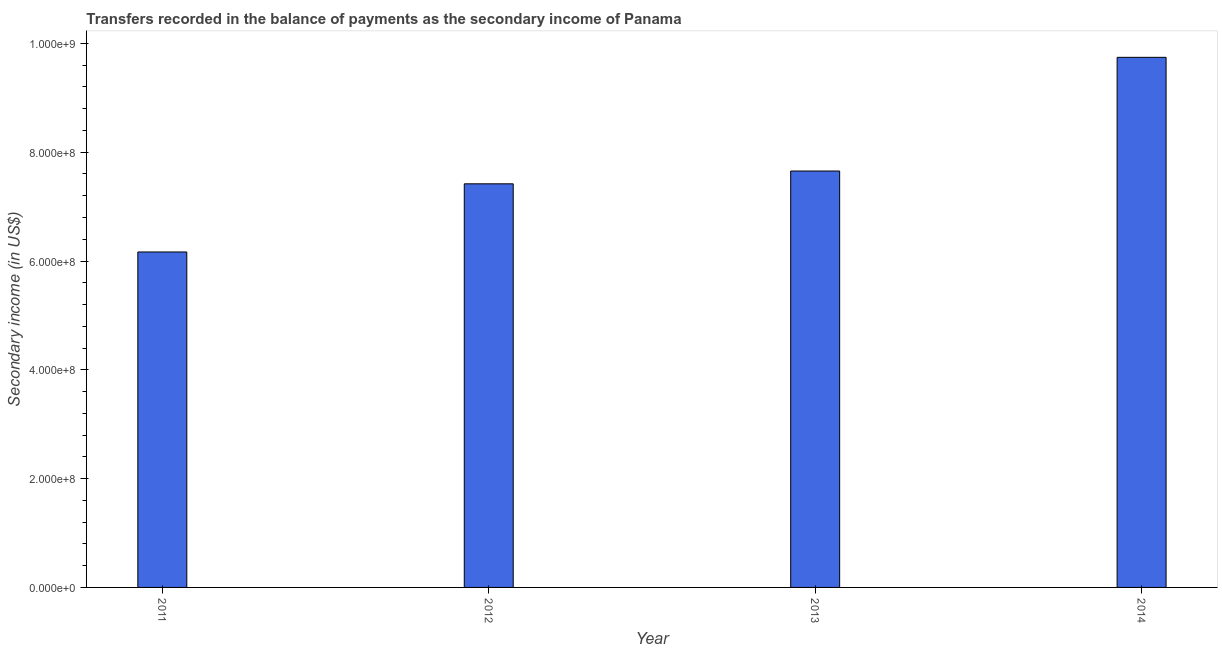Does the graph contain any zero values?
Ensure brevity in your answer.  No. What is the title of the graph?
Keep it short and to the point. Transfers recorded in the balance of payments as the secondary income of Panama. What is the label or title of the X-axis?
Ensure brevity in your answer.  Year. What is the label or title of the Y-axis?
Your answer should be very brief. Secondary income (in US$). What is the amount of secondary income in 2013?
Your response must be concise. 7.65e+08. Across all years, what is the maximum amount of secondary income?
Provide a succinct answer. 9.74e+08. Across all years, what is the minimum amount of secondary income?
Keep it short and to the point. 6.17e+08. What is the sum of the amount of secondary income?
Give a very brief answer. 3.10e+09. What is the difference between the amount of secondary income in 2011 and 2013?
Your response must be concise. -1.49e+08. What is the average amount of secondary income per year?
Your answer should be very brief. 7.75e+08. What is the median amount of secondary income?
Make the answer very short. 7.54e+08. What is the ratio of the amount of secondary income in 2012 to that in 2013?
Your response must be concise. 0.97. Is the amount of secondary income in 2012 less than that in 2013?
Provide a short and direct response. Yes. Is the difference between the amount of secondary income in 2012 and 2013 greater than the difference between any two years?
Ensure brevity in your answer.  No. What is the difference between the highest and the second highest amount of secondary income?
Provide a succinct answer. 2.09e+08. Is the sum of the amount of secondary income in 2013 and 2014 greater than the maximum amount of secondary income across all years?
Provide a short and direct response. Yes. What is the difference between the highest and the lowest amount of secondary income?
Ensure brevity in your answer.  3.58e+08. What is the difference between two consecutive major ticks on the Y-axis?
Your response must be concise. 2.00e+08. What is the Secondary income (in US$) in 2011?
Make the answer very short. 6.17e+08. What is the Secondary income (in US$) of 2012?
Offer a very short reply. 7.42e+08. What is the Secondary income (in US$) in 2013?
Your answer should be very brief. 7.65e+08. What is the Secondary income (in US$) in 2014?
Offer a very short reply. 9.74e+08. What is the difference between the Secondary income (in US$) in 2011 and 2012?
Your answer should be compact. -1.25e+08. What is the difference between the Secondary income (in US$) in 2011 and 2013?
Make the answer very short. -1.49e+08. What is the difference between the Secondary income (in US$) in 2011 and 2014?
Make the answer very short. -3.58e+08. What is the difference between the Secondary income (in US$) in 2012 and 2013?
Provide a succinct answer. -2.35e+07. What is the difference between the Secondary income (in US$) in 2012 and 2014?
Offer a terse response. -2.32e+08. What is the difference between the Secondary income (in US$) in 2013 and 2014?
Your answer should be very brief. -2.09e+08. What is the ratio of the Secondary income (in US$) in 2011 to that in 2012?
Offer a very short reply. 0.83. What is the ratio of the Secondary income (in US$) in 2011 to that in 2013?
Provide a short and direct response. 0.81. What is the ratio of the Secondary income (in US$) in 2011 to that in 2014?
Provide a short and direct response. 0.63. What is the ratio of the Secondary income (in US$) in 2012 to that in 2014?
Provide a short and direct response. 0.76. What is the ratio of the Secondary income (in US$) in 2013 to that in 2014?
Your answer should be very brief. 0.79. 